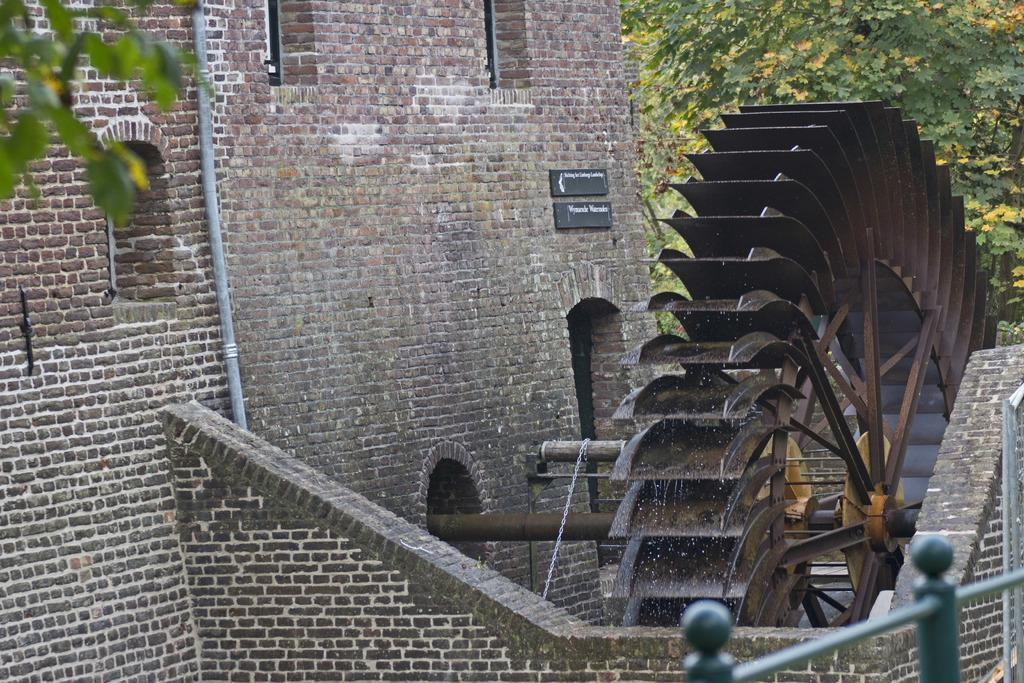What is the main structure in the image? There is a building in the middle of the image. What is on top of the building? There is a machine on the building. What can be seen behind the machine? There is a tree behind the machine. What is located in the bottom right corner of the image? There is fencing in the bottom right corner of the image. What type of skate is being used to exchange wristbands in the image? There is no skate or wristbands present in the image. What type of wrist is visible in the image? There is no wrist visible in the image. 